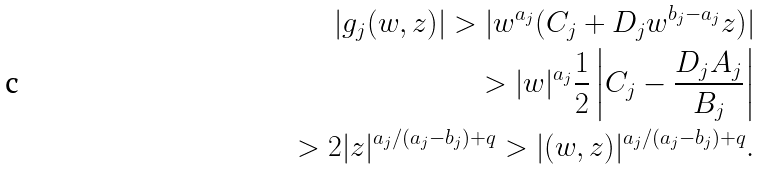<formula> <loc_0><loc_0><loc_500><loc_500>| g _ { j } ( w , z ) | > | w ^ { a _ { j } } ( C _ { j } + D _ { j } w ^ { b _ { j } - a _ { j } } z ) | \\ > | w | ^ { a _ { j } } \frac { 1 } { 2 } \left | C _ { j } - \frac { D _ { j } A _ { j } } { B _ { j } } \right | \\ > 2 | z | ^ { a _ { j } / ( a _ { j } - b _ { j } ) + q } > | ( w , z ) | ^ { a _ { j } / ( a _ { j } - b _ { j } ) + q } .</formula> 